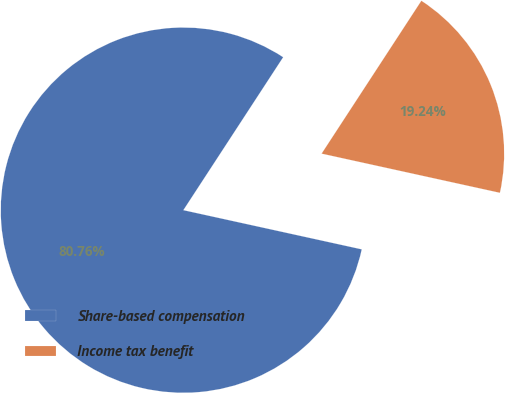Convert chart to OTSL. <chart><loc_0><loc_0><loc_500><loc_500><pie_chart><fcel>Share-based compensation<fcel>Income tax benefit<nl><fcel>80.76%<fcel>19.24%<nl></chart> 